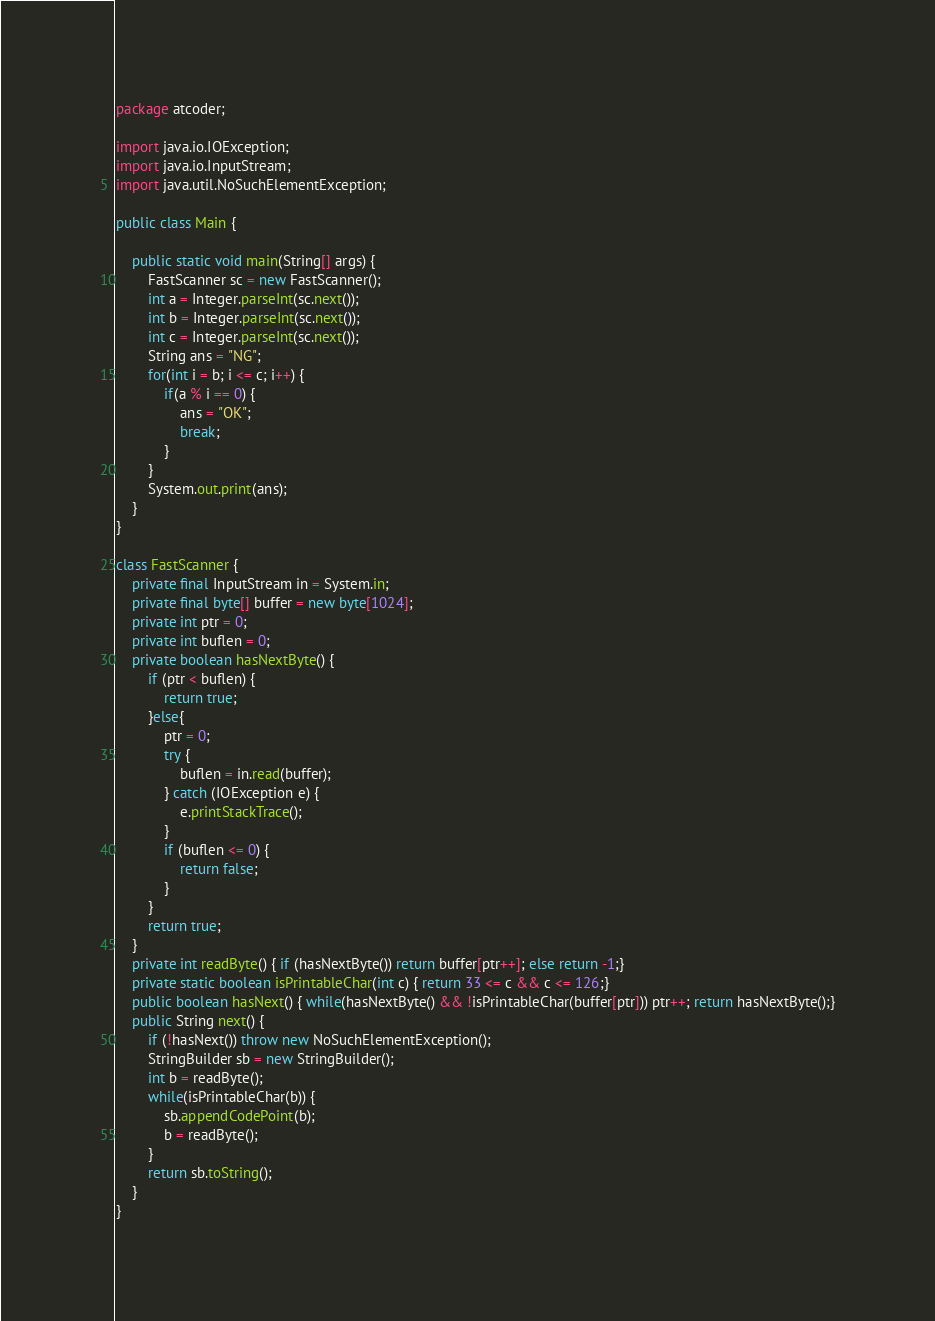Convert code to text. <code><loc_0><loc_0><loc_500><loc_500><_Java_>package atcoder;

import java.io.IOException;
import java.io.InputStream;
import java.util.NoSuchElementException;

public class Main {

	public static void main(String[] args) {
		FastScanner sc = new FastScanner();
		int a = Integer.parseInt(sc.next());
		int b = Integer.parseInt(sc.next());
		int c = Integer.parseInt(sc.next());
		String ans = "NG";
		for(int i = b; i <= c; i++) {
			if(a % i == 0) {
				ans = "OK";
				break;
			}
		}
		System.out.print(ans);
	}
}

class FastScanner {
    private final InputStream in = System.in;
    private final byte[] buffer = new byte[1024];
    private int ptr = 0;
    private int buflen = 0;
    private boolean hasNextByte() {
        if (ptr < buflen) {
            return true;
        }else{
            ptr = 0;
            try {
                buflen = in.read(buffer);
            } catch (IOException e) {
                e.printStackTrace();
            }
            if (buflen <= 0) {
                return false;
            }
        }
        return true;
    }
    private int readByte() { if (hasNextByte()) return buffer[ptr++]; else return -1;}
    private static boolean isPrintableChar(int c) { return 33 <= c && c <= 126;}
    public boolean hasNext() { while(hasNextByte() && !isPrintableChar(buffer[ptr])) ptr++; return hasNextByte();}
    public String next() {
        if (!hasNext()) throw new NoSuchElementException();
        StringBuilder sb = new StringBuilder();
        int b = readByte();
        while(isPrintableChar(b)) {
            sb.appendCodePoint(b);
            b = readByte();
        }
        return sb.toString();
    }
}
</code> 